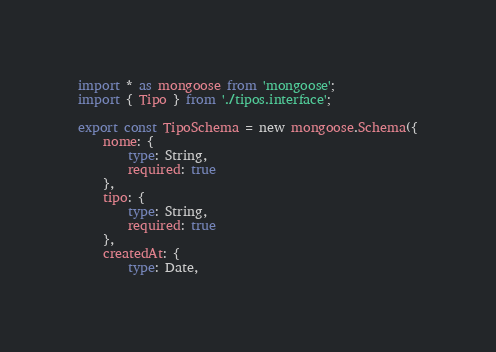Convert code to text. <code><loc_0><loc_0><loc_500><loc_500><_TypeScript_>import * as mongoose from 'mongoose';
import { Tipo } from './tipos.interface';

export const TipoSchema = new mongoose.Schema({
    nome: {
        type: String,
        required: true
    },
    tipo: {
        type: String,
        required: true
    },
    createdAt: {
        type: Date, </code> 